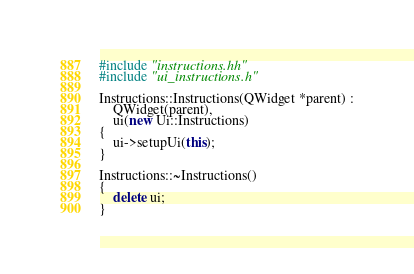Convert code to text. <code><loc_0><loc_0><loc_500><loc_500><_C++_>#include "instructions.hh"
#include "ui_instructions.h"

Instructions::Instructions(QWidget *parent) :
    QWidget(parent),
    ui(new Ui::Instructions)
{
    ui->setupUi(this);
}

Instructions::~Instructions()
{
    delete ui;
}
</code> 